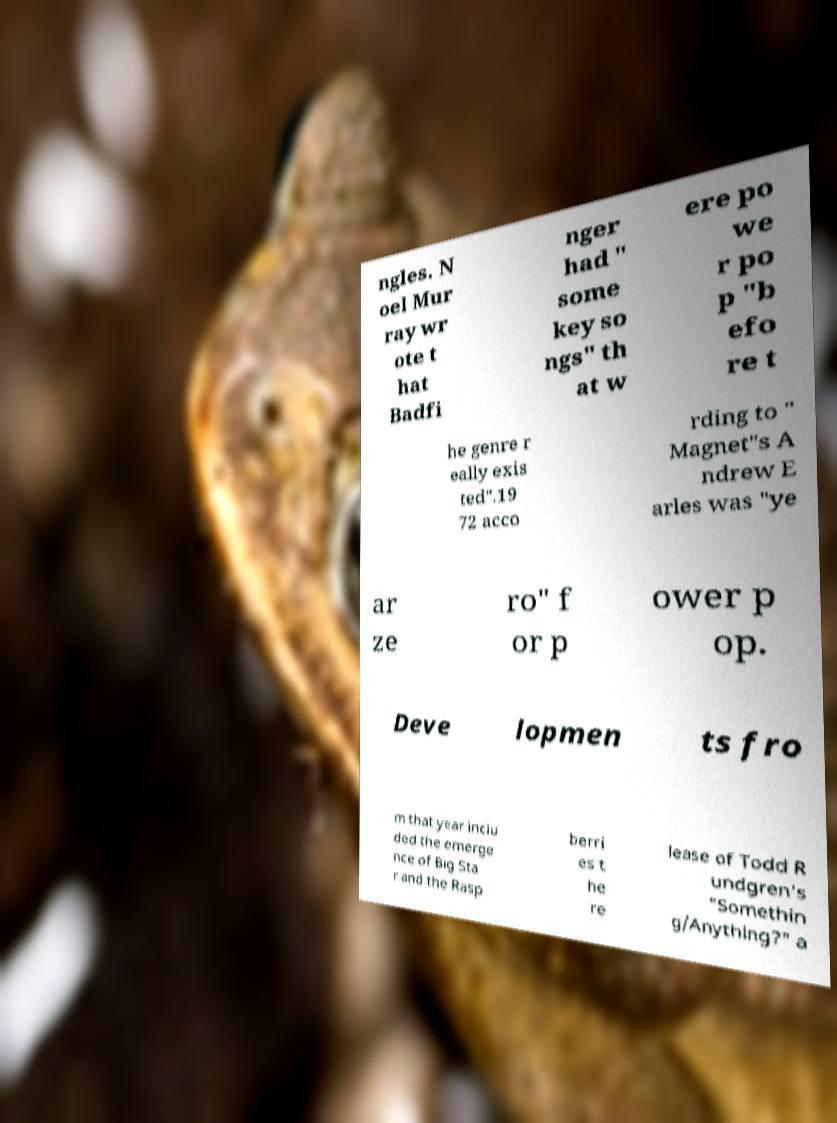Can you accurately transcribe the text from the provided image for me? ngles. N oel Mur ray wr ote t hat Badfi nger had " some key so ngs" th at w ere po we r po p "b efo re t he genre r eally exis ted".19 72 acco rding to " Magnet"s A ndrew E arles was "ye ar ze ro" f or p ower p op. Deve lopmen ts fro m that year inclu ded the emerge nce of Big Sta r and the Rasp berri es t he re lease of Todd R undgren's "Somethin g/Anything?" a 